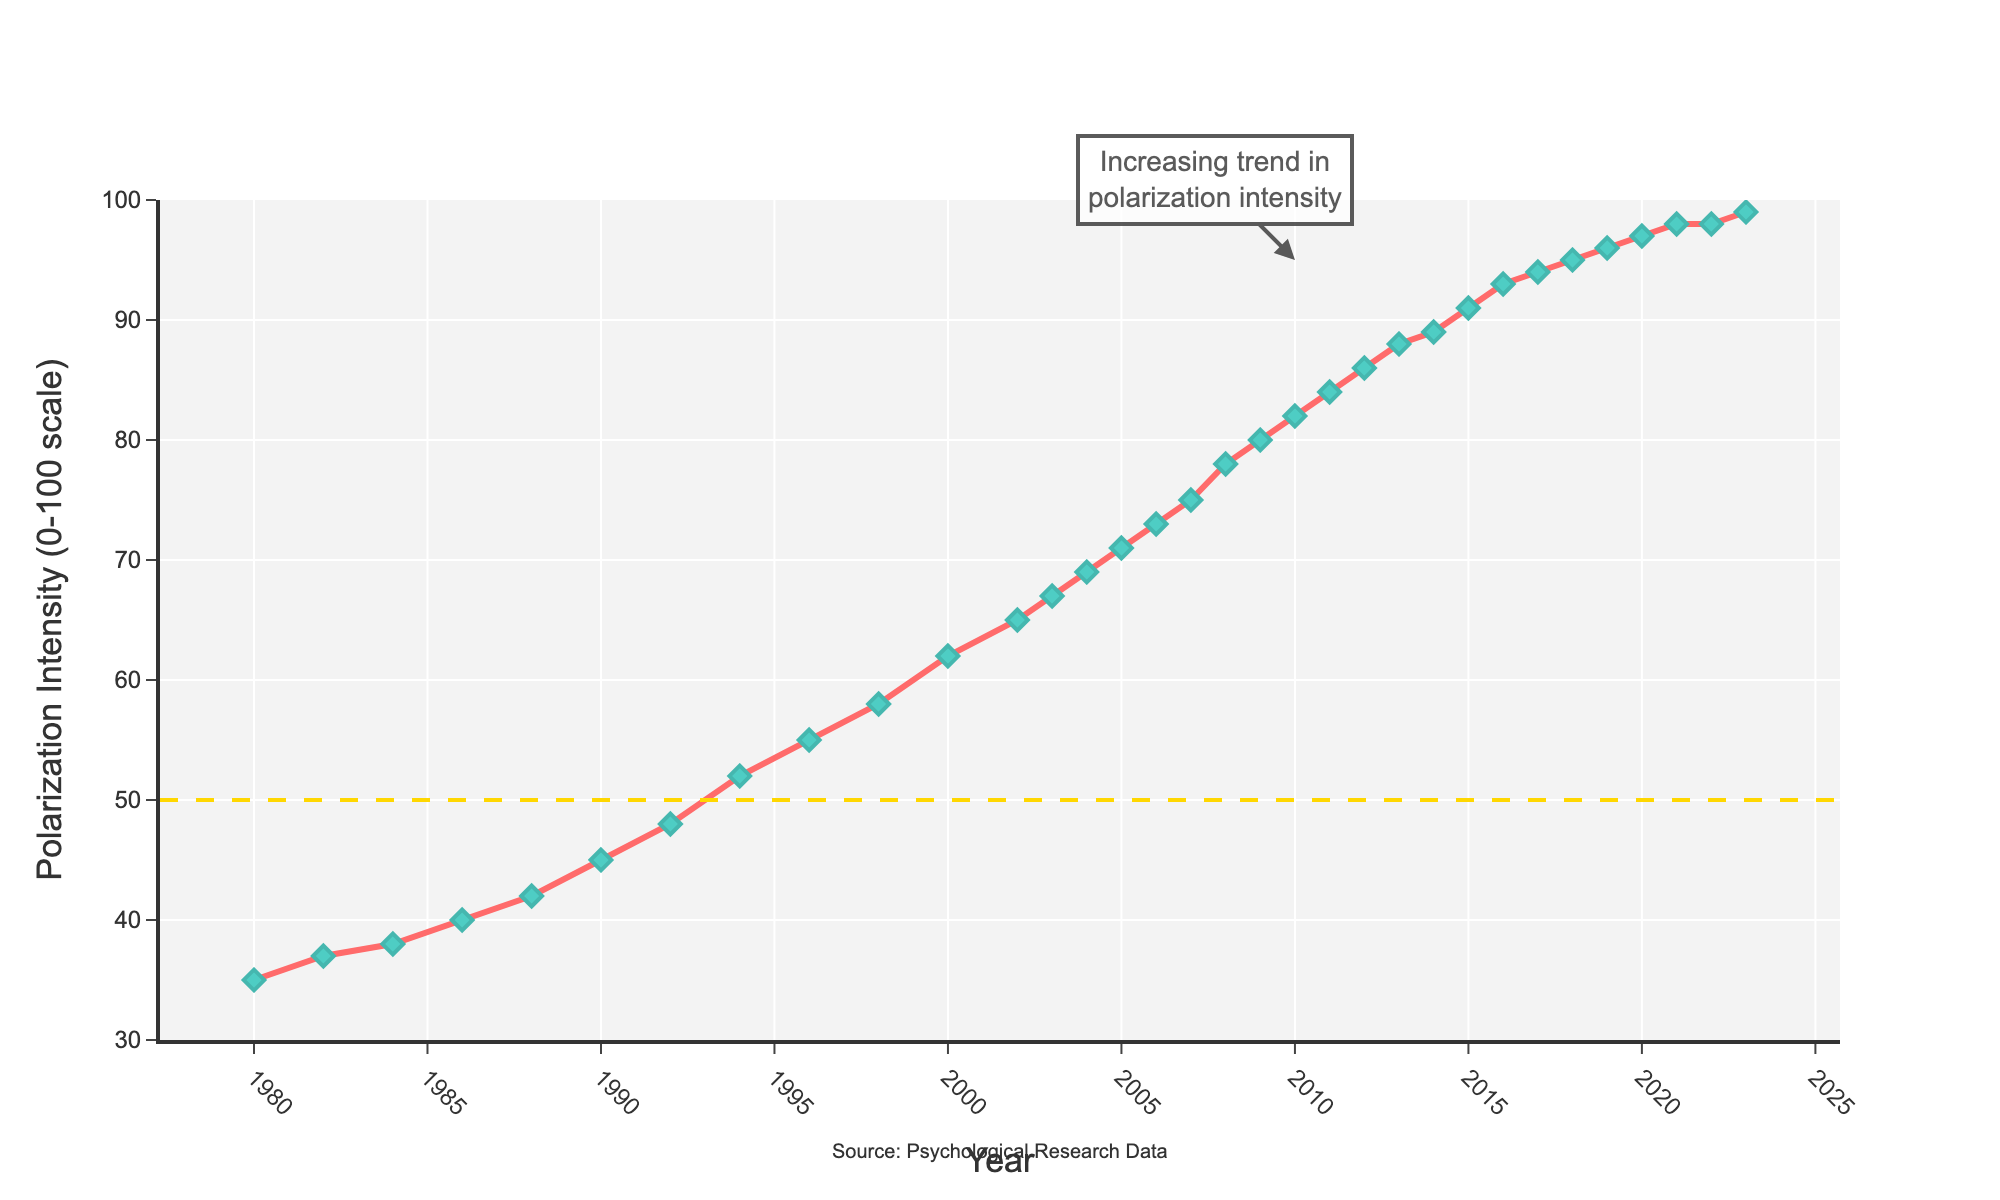What was the Polarization Intensity in the year 2000? Locate the year 2000 on the x-axis and find the corresponding value on the y-axis, which is labeled as "Polarization Intensity (0-100 scale)" in the chart.
Answer: 62 What is the difference in Polarization Intensity between 1980 and 2023? Subtract the Polarization Intensity value of 1980 (35) from the Polarization Intensity value of 2023 (99).
Answer: 64 How does the Polarization Intensity in 1990 compare to that in 2010? Find the values for the years 1990 (45) and 2010 (82) and compare them. Since 82 is greater than 45, Polarization Intensity in 2010 is higher than in 1990.
Answer: Higher Between what years did the Polarization Intensity first reach 50? Locate the horizontal dashed line at the y-value of 50 and find where this intersects the upward trend in the line plot. The intersection occurs between the years 1992 (48) and 1994 (52).
Answer: Between 1992 and 1994 What is the average Polarization Intensity from 1980 to 1990? Add the Polarization Intensity values from 1980 (35), 1982 (37), 1984 (38), 1986 (40), 1988 (42), and 1990 (45). Then divide by the number of years: (35 + 37 + 38 + 40 + 42 + 45)/6 = 237/6 = 39.5
Answer: 39.5 In which decade did the most significant increase in Polarization Intensity occur? Examine the plot to identify where the steepest slope (i.e., the largest change in y-value) occurs. From 2000 (62) to 2010 (82) represents a significant increase. Calculate the change: 82 - 62 = 20
Answer: 2000-2010 What is the average annual increase in Polarization Intensity from 2000 to 2010? Find the difference in intensities between 2010 (82) and 2000 (62), which is 20. Divide this difference by the number of years (10): 20/10 = 2
Answer: 2 How does the intensity in 2008 compare to that in 2018? Compare the plotted values for the years 2008 (78) and 2018 (95). Note that 95 is greater than 78, indicating that the 2018 intensity is higher.
Answer: Higher What's the median Polarization Intensity value for the data points between 2010 and 2020? Extract the Polarization Intensities for the years 2010 (82), 2011 (84), 2012 (86), 2013 (88), 2014 (89), 2015 (91), 2016 (93), 2017 (94), 2018 (95), and 2019 (96). Sort: [82, 84, 86, 88, 89, 91, 93, 94, 95, 96]. The median value is the average of the 5th and 6th elements: (89 + 91)/2 = 180/2 = 90
Answer: 90 By how many points did the Polarization Intensity increase from 1980 to 1986? Subtract the Polarization Intensity value of 1980 (35) from the value of 1986 (40): 40 - 35 = 5
Answer: 5 